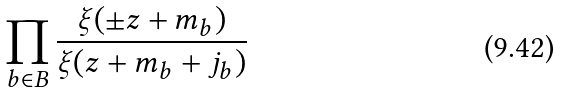<formula> <loc_0><loc_0><loc_500><loc_500>\prod _ { b \in B } \frac { \xi ( \pm z + m _ { b } ) } { \xi ( z + m _ { b } + j _ { b } ) }</formula> 